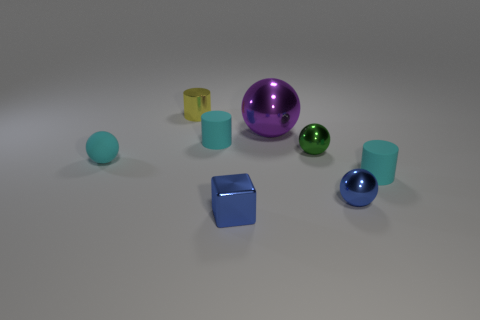How many groups of objects can you classify based on their shapes? Given the variety in the image, objects can be classified into two primary shape groups: spherical, which includes the large purple sphere and two smaller spheres; and cuboidal, consisting of the blue cube and several cylinders with varying heights. 